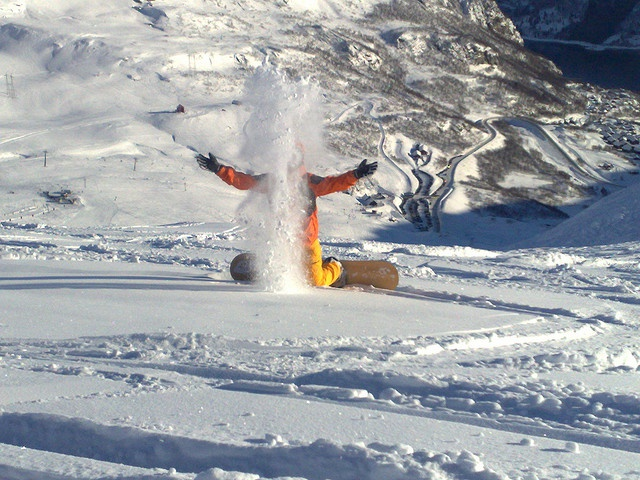Describe the objects in this image and their specific colors. I can see people in beige, gray, brown, and orange tones and snowboard in beige, gray, darkgray, and brown tones in this image. 